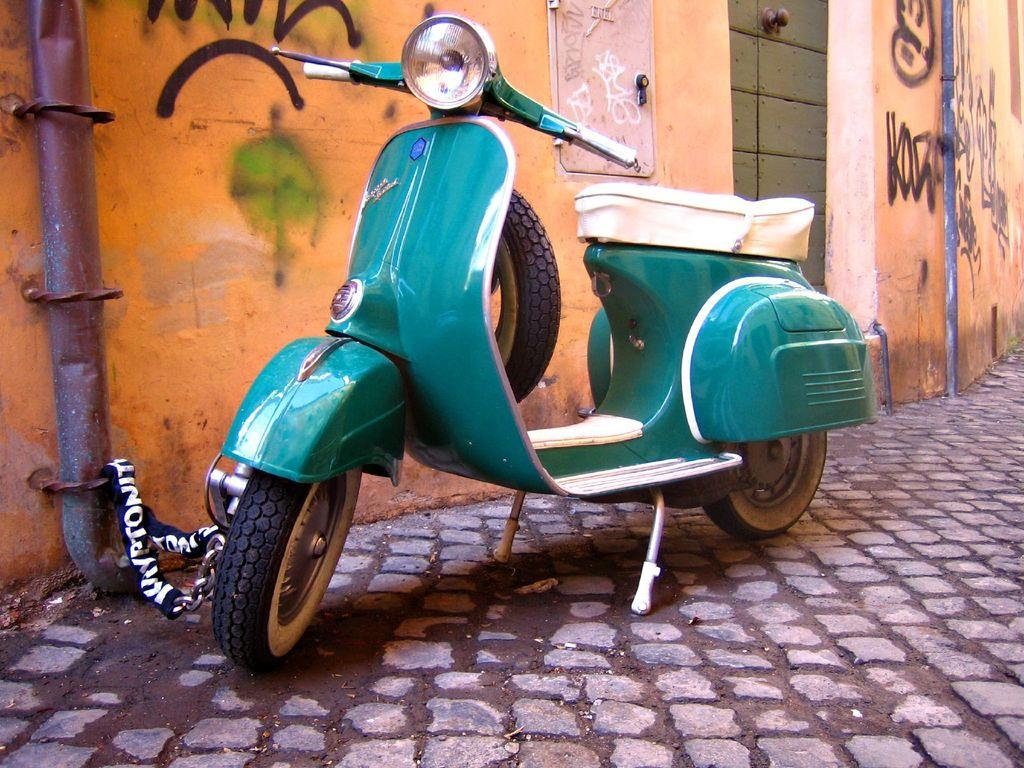What type of vehicle is in the image? There is a scooter in the image. Where is the scooter located? The scooter is on the footpath. What else can be seen in the image? There is a wall in the image. What type of sound can be heard coming from the governor's office in the image? There is no governor's office or sound present in the image; it only features a scooter on the footpath and a wall. 